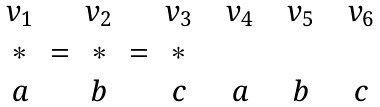<formula> <loc_0><loc_0><loc_500><loc_500>\begin{array} { c c c c c c c c c c c } v _ { 1 } & & v _ { 2 } & & v _ { 3 } & & v _ { 4 } & & v _ { 5 } & & v _ { 6 } \\ \ast & = & \ast & = & \ast \\ a & & b & & c & & a & & b & & c \end{array}</formula> 